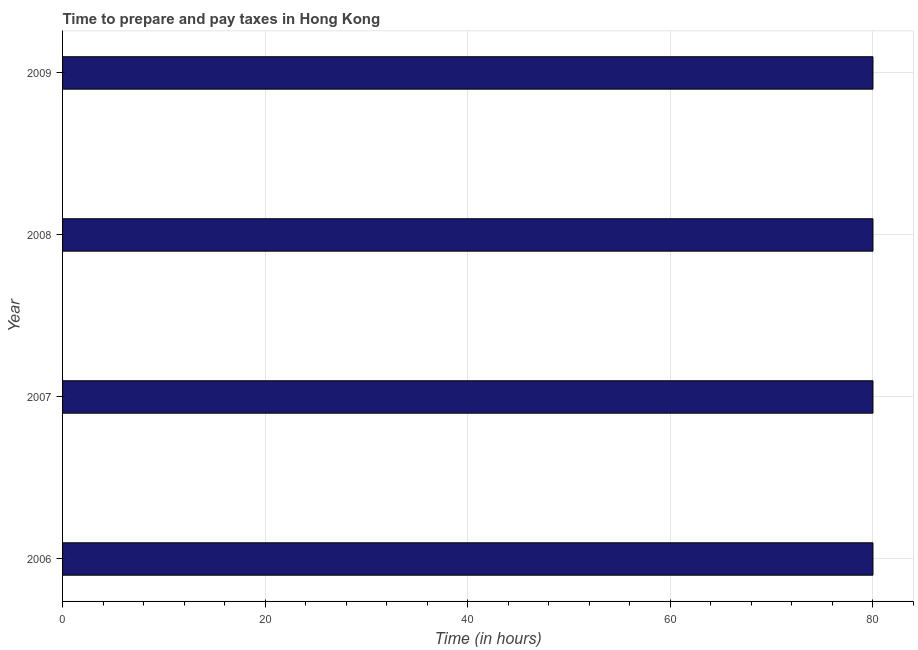Does the graph contain grids?
Keep it short and to the point. Yes. What is the title of the graph?
Offer a very short reply. Time to prepare and pay taxes in Hong Kong. What is the label or title of the X-axis?
Make the answer very short. Time (in hours). What is the time to prepare and pay taxes in 2006?
Keep it short and to the point. 80. Across all years, what is the minimum time to prepare and pay taxes?
Offer a very short reply. 80. In which year was the time to prepare and pay taxes minimum?
Ensure brevity in your answer.  2006. What is the sum of the time to prepare and pay taxes?
Provide a short and direct response. 320. In how many years, is the time to prepare and pay taxes greater than 80 hours?
Make the answer very short. 0. Do a majority of the years between 2009 and 2007 (inclusive) have time to prepare and pay taxes greater than 40 hours?
Offer a terse response. Yes. What is the ratio of the time to prepare and pay taxes in 2008 to that in 2009?
Give a very brief answer. 1. What is the difference between the highest and the lowest time to prepare and pay taxes?
Provide a short and direct response. 0. In how many years, is the time to prepare and pay taxes greater than the average time to prepare and pay taxes taken over all years?
Your answer should be compact. 0. Are all the bars in the graph horizontal?
Provide a succinct answer. Yes. How many years are there in the graph?
Keep it short and to the point. 4. What is the Time (in hours) of 2008?
Provide a succinct answer. 80. What is the Time (in hours) in 2009?
Keep it short and to the point. 80. What is the difference between the Time (in hours) in 2006 and 2007?
Your response must be concise. 0. What is the difference between the Time (in hours) in 2006 and 2008?
Your answer should be very brief. 0. What is the difference between the Time (in hours) in 2007 and 2008?
Provide a short and direct response. 0. What is the difference between the Time (in hours) in 2008 and 2009?
Your response must be concise. 0. What is the ratio of the Time (in hours) in 2006 to that in 2007?
Give a very brief answer. 1. What is the ratio of the Time (in hours) in 2006 to that in 2008?
Provide a succinct answer. 1. What is the ratio of the Time (in hours) in 2007 to that in 2009?
Provide a succinct answer. 1. What is the ratio of the Time (in hours) in 2008 to that in 2009?
Your response must be concise. 1. 